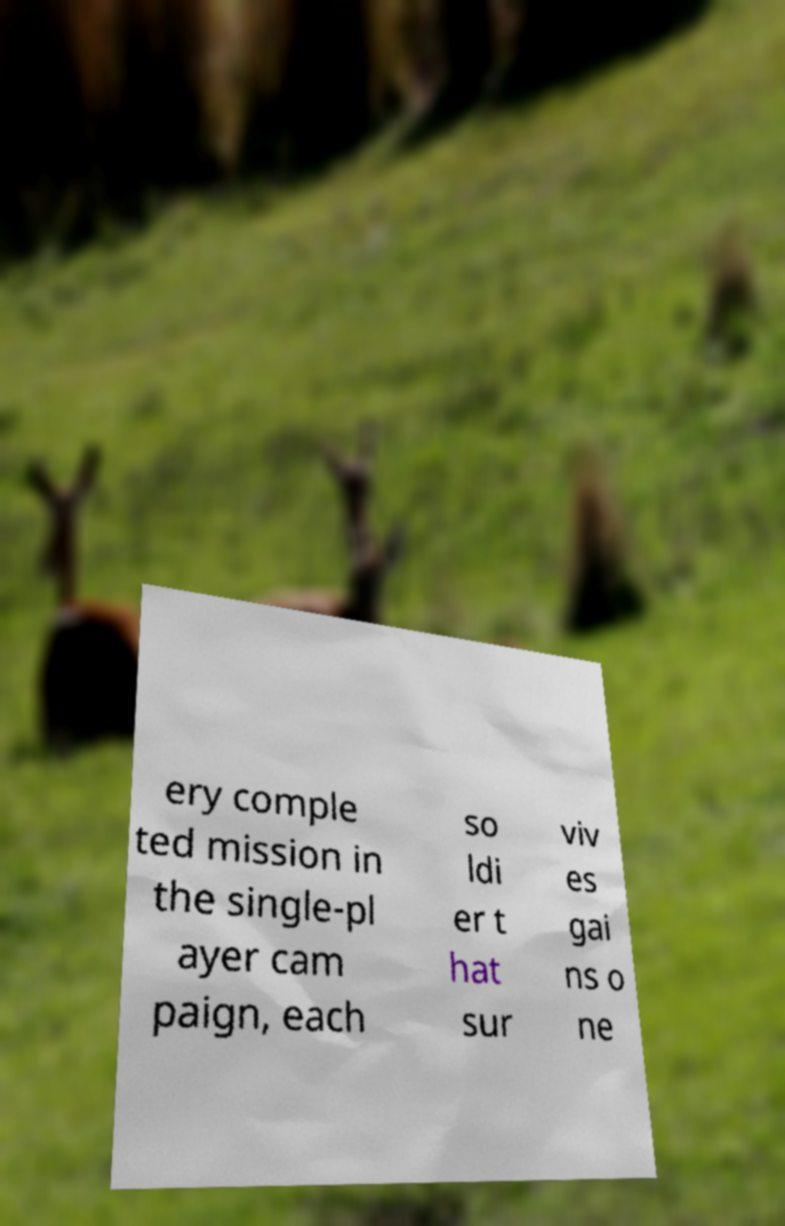There's text embedded in this image that I need extracted. Can you transcribe it verbatim? ery comple ted mission in the single-pl ayer cam paign, each so ldi er t hat sur viv es gai ns o ne 